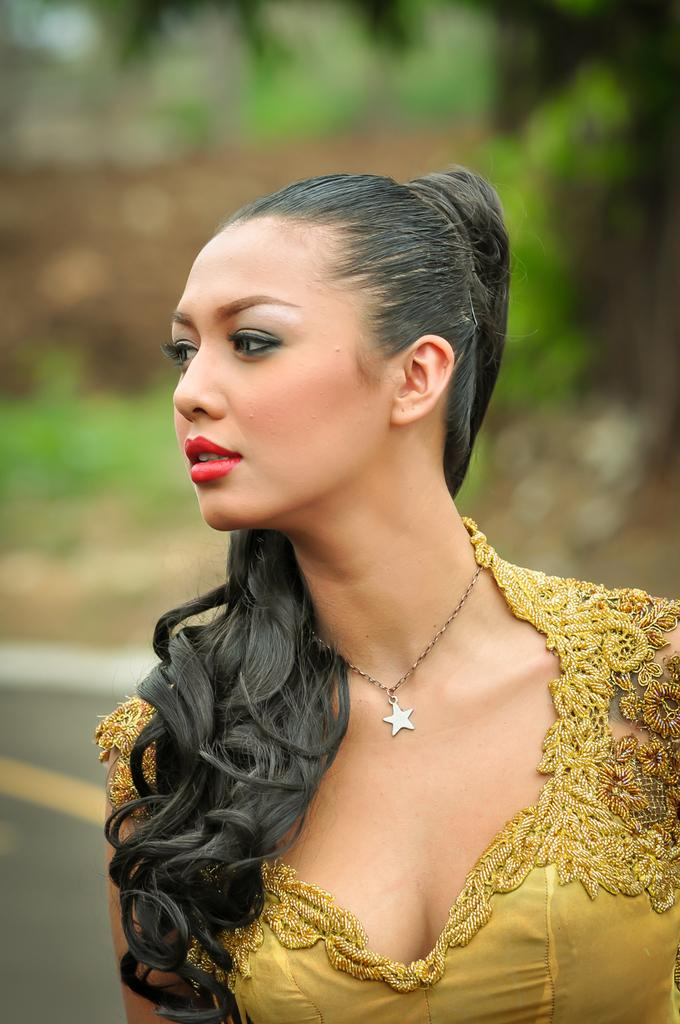Who is present in the image? There is a woman in the image. What is the woman wearing? The woman is wearing clothes and a neck chain. What can be seen in the foreground of the image? There is a road visible in the image. How would you describe the background of the image? The background of the image is blurred. Can you hear the woman coughing in the image? There is no sound in the image, so it is not possible to hear the woman coughing. 